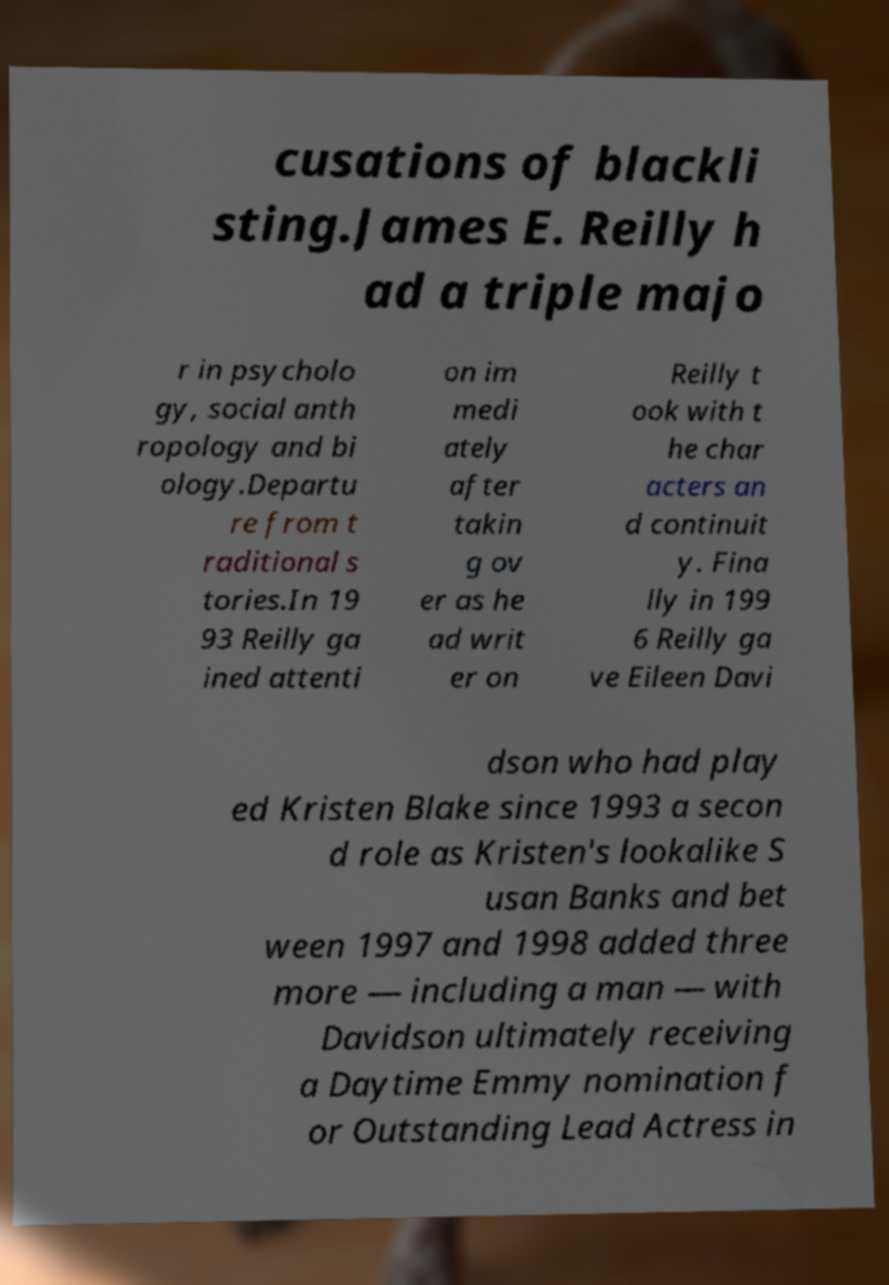Could you extract and type out the text from this image? cusations of blackli sting.James E. Reilly h ad a triple majo r in psycholo gy, social anth ropology and bi ology.Departu re from t raditional s tories.In 19 93 Reilly ga ined attenti on im medi ately after takin g ov er as he ad writ er on Reilly t ook with t he char acters an d continuit y. Fina lly in 199 6 Reilly ga ve Eileen Davi dson who had play ed Kristen Blake since 1993 a secon d role as Kristen's lookalike S usan Banks and bet ween 1997 and 1998 added three more — including a man — with Davidson ultimately receiving a Daytime Emmy nomination f or Outstanding Lead Actress in 